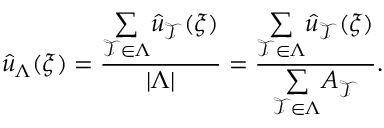<formula> <loc_0><loc_0><loc_500><loc_500>\hat { u } _ { \Lambda } ( \xi ) = \frac { \underset { \mathcal { T } \in \Lambda } { \sum } \hat { u } _ { \mathcal { T } } ( \xi ) } { | \Lambda | } = \frac { \underset { \mathcal { T } \in \Lambda } { \sum } \hat { u } _ { \mathcal { T } } ( \xi ) } { \underset { \mathcal { T } \in \Lambda } { \sum } A _ { \mathcal { T } } } .</formula> 